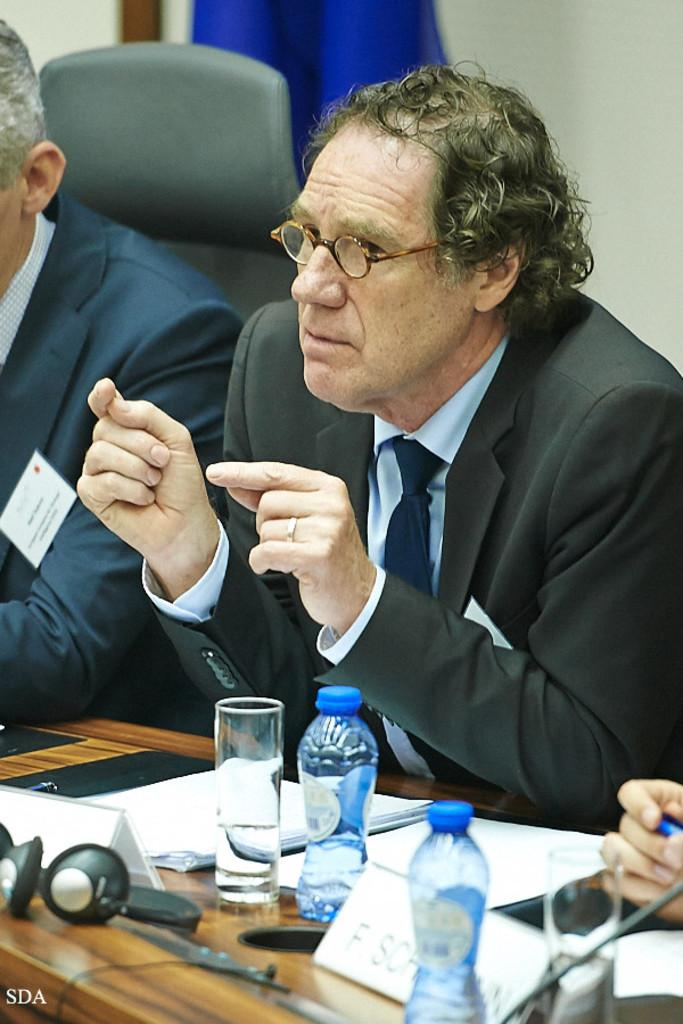How many men are sitting in the image? There are two men sitting in the image. Can you describe the appearance of one of the men? One of the men is wearing glasses (specs) and a suit. What items can be seen on the table in the image? There are bottles, glasses, and a headphone on the table in the image. What songs are being played on the headphones in the image? There are no songs being played in the image, as the headphones are on the table and not being used. 